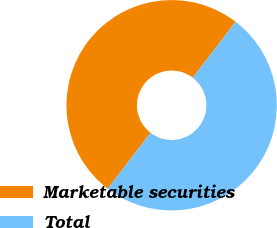<chart> <loc_0><loc_0><loc_500><loc_500><pie_chart><fcel>Marketable securities<fcel>Total<nl><fcel>50.0%<fcel>50.0%<nl></chart> 